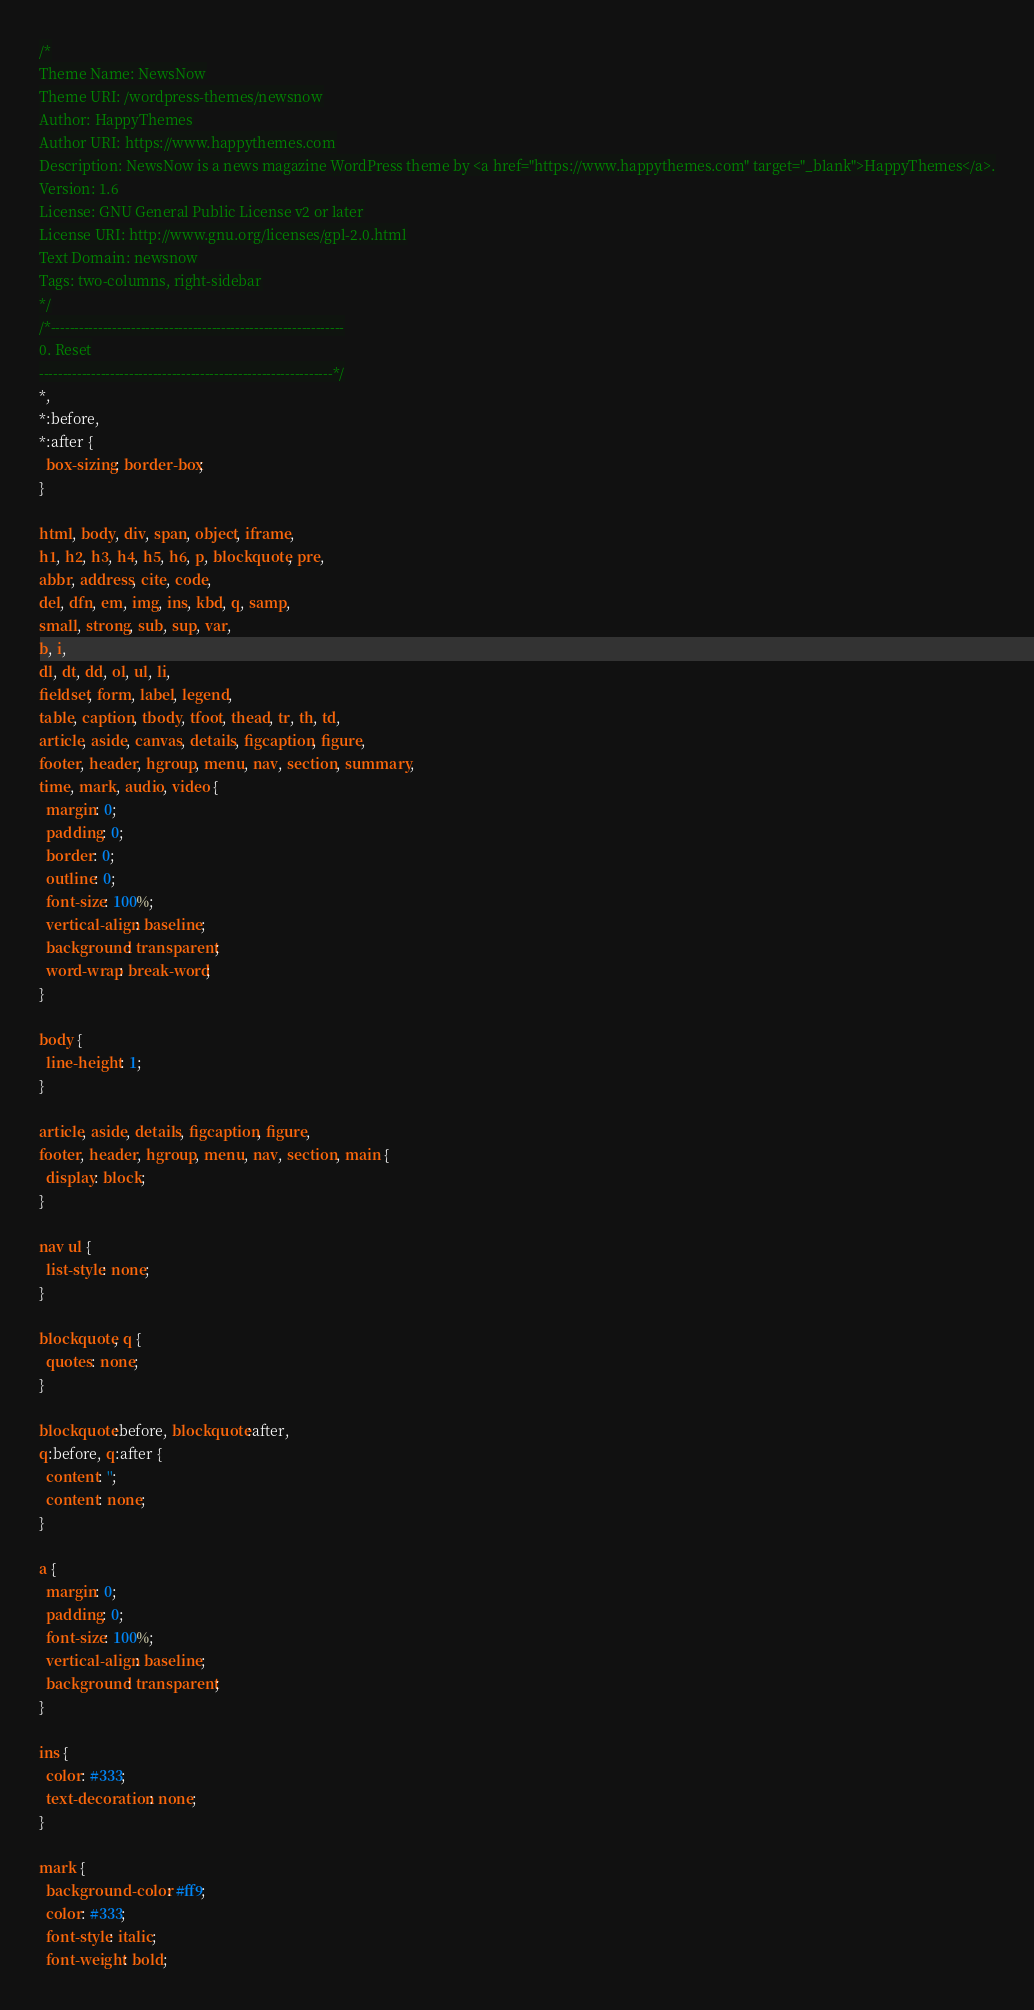<code> <loc_0><loc_0><loc_500><loc_500><_CSS_>/*
Theme Name: NewsNow
Theme URI: /wordpress-themes/newsnow
Author: HappyThemes
Author URI: https://www.happythemes.com
Description: NewsNow is a news magazine WordPress theme by <a href="https://www.happythemes.com" target="_blank">HappyThemes</a>.
Version: 1.6
License: GNU General Public License v2 or later
License URI: http://www.gnu.org/licenses/gpl-2.0.html
Text Domain: newsnow
Tags: two-columns, right-sidebar
*/
/*--------------------------------------------------------------
0. Reset
--------------------------------------------------------------*/
*,
*:before,
*:after {
  box-sizing: border-box;
}

html, body, div, span, object, iframe,
h1, h2, h3, h4, h5, h6, p, blockquote, pre,
abbr, address, cite, code,
del, dfn, em, img, ins, kbd, q, samp,
small, strong, sub, sup, var,
b, i,
dl, dt, dd, ol, ul, li,
fieldset, form, label, legend,
table, caption, tbody, tfoot, thead, tr, th, td,
article, aside, canvas, details, figcaption, figure,
footer, header, hgroup, menu, nav, section, summary,
time, mark, audio, video {
  margin: 0;
  padding: 0;
  border: 0;
  outline: 0;
  font-size: 100%;
  vertical-align: baseline;
  background: transparent;
  word-wrap: break-word;
}

body {
  line-height: 1;
}

article, aside, details, figcaption, figure,
footer, header, hgroup, menu, nav, section, main {
  display: block;
}

nav ul {
  list-style: none;
}

blockquote, q {
  quotes: none;
}

blockquote:before, blockquote:after,
q:before, q:after {
  content: '';
  content: none;
}

a {
  margin: 0;
  padding: 0;
  font-size: 100%;
  vertical-align: baseline;
  background: transparent;
}

ins {
  color: #333;
  text-decoration: none;
}

mark {
  background-color: #ff9;
  color: #333;
  font-style: italic;
  font-weight: bold;</code> 